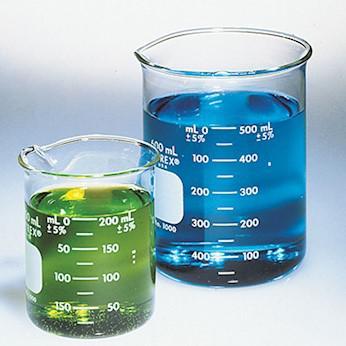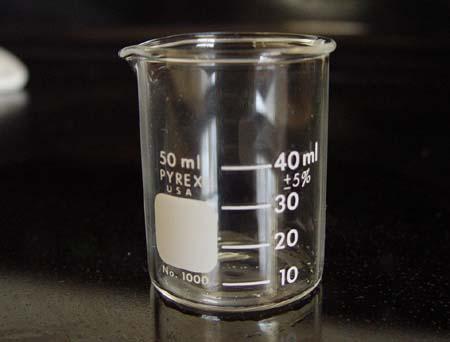The first image is the image on the left, the second image is the image on the right. Given the left and right images, does the statement "One beaker contains at least 500 ml of liquid." hold true? Answer yes or no. Yes. 